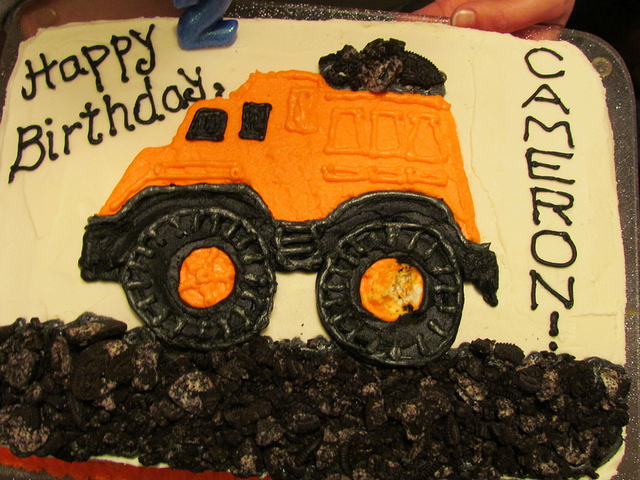Extract all visible text content from this image. Happy Birthday, CAMERONI 